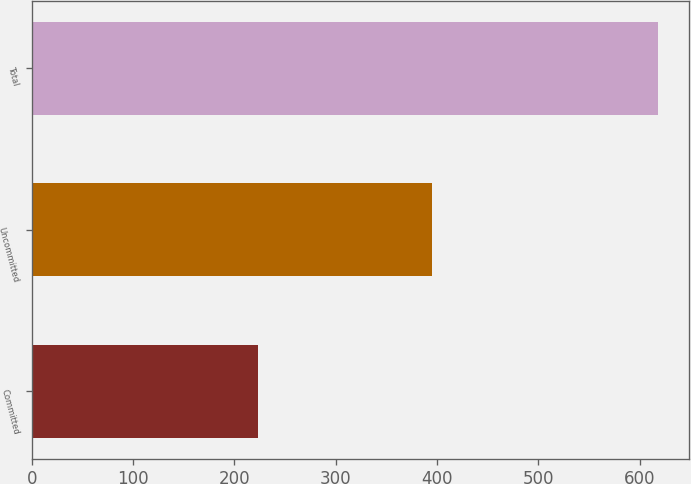Convert chart to OTSL. <chart><loc_0><loc_0><loc_500><loc_500><bar_chart><fcel>Committed<fcel>Uncommitted<fcel>Total<nl><fcel>223<fcel>395<fcel>618<nl></chart> 